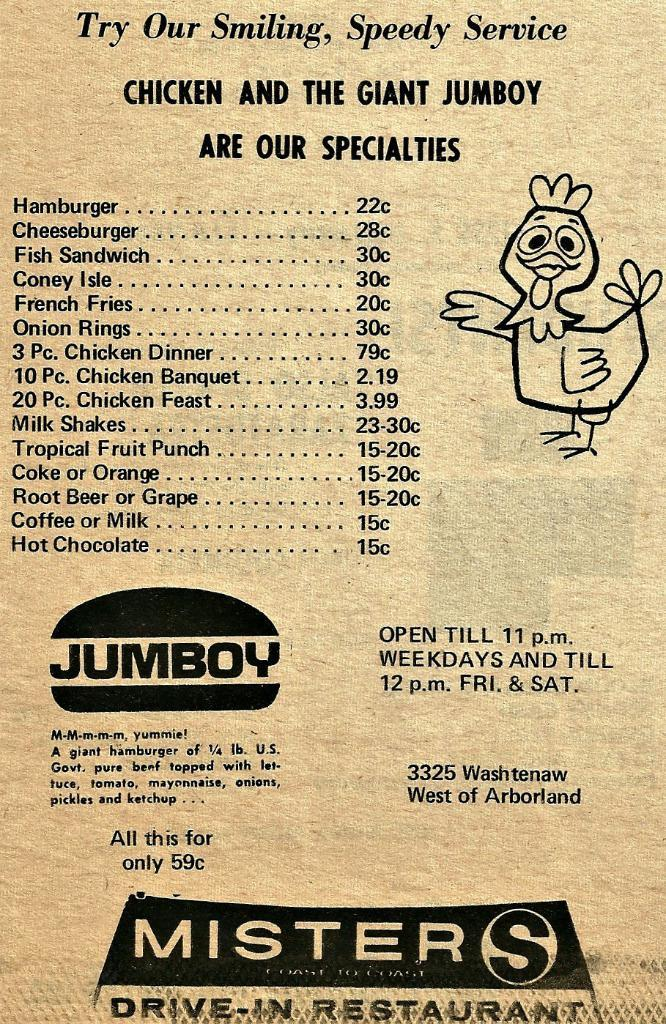<image>
Describe the image concisely. A menu for Misters Drive-In Restaruant with a chicken on it 